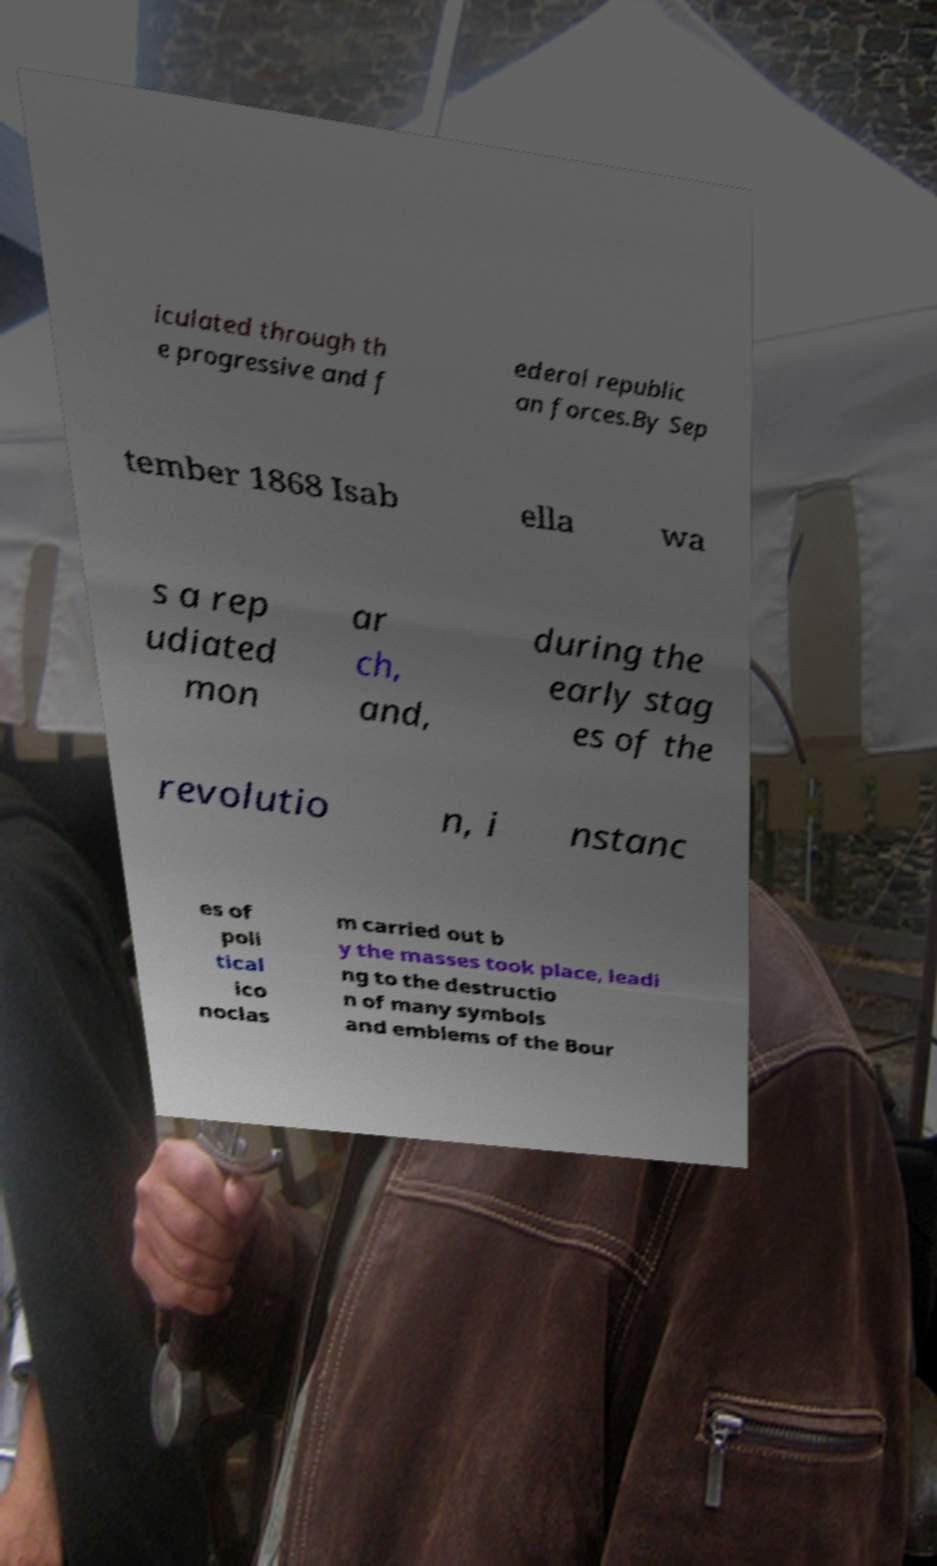Can you accurately transcribe the text from the provided image for me? iculated through th e progressive and f ederal republic an forces.By Sep tember 1868 Isab ella wa s a rep udiated mon ar ch, and, during the early stag es of the revolutio n, i nstanc es of poli tical ico noclas m carried out b y the masses took place, leadi ng to the destructio n of many symbols and emblems of the Bour 